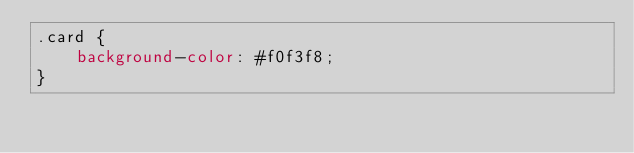<code> <loc_0><loc_0><loc_500><loc_500><_CSS_>.card {
    background-color: #f0f3f8;
}</code> 